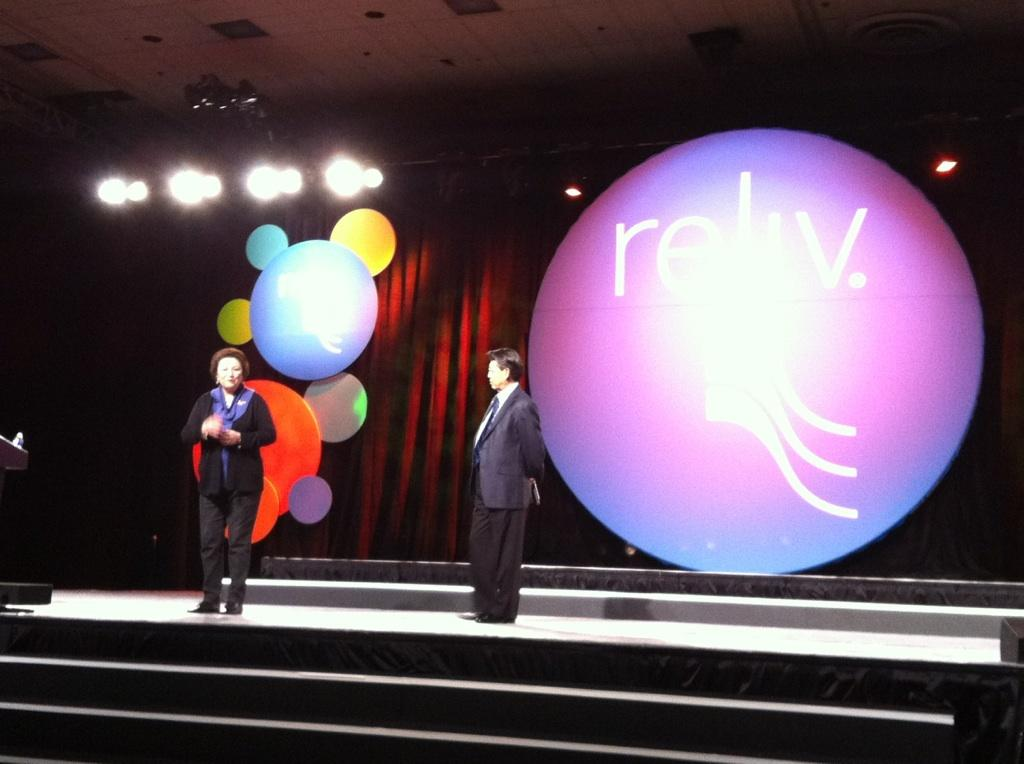How many people are on the stage in the image? There are two people on the stage in the image. What can be seen in the background behind the stage? There is a curtain and lights in the background. What type of vase is placed on the stage in the image? There is no vase present on the stage in the image. Can you describe the owl sitting on the curtain in the background? There is no owl present in the image; only the curtain and lights are visible in the background. 